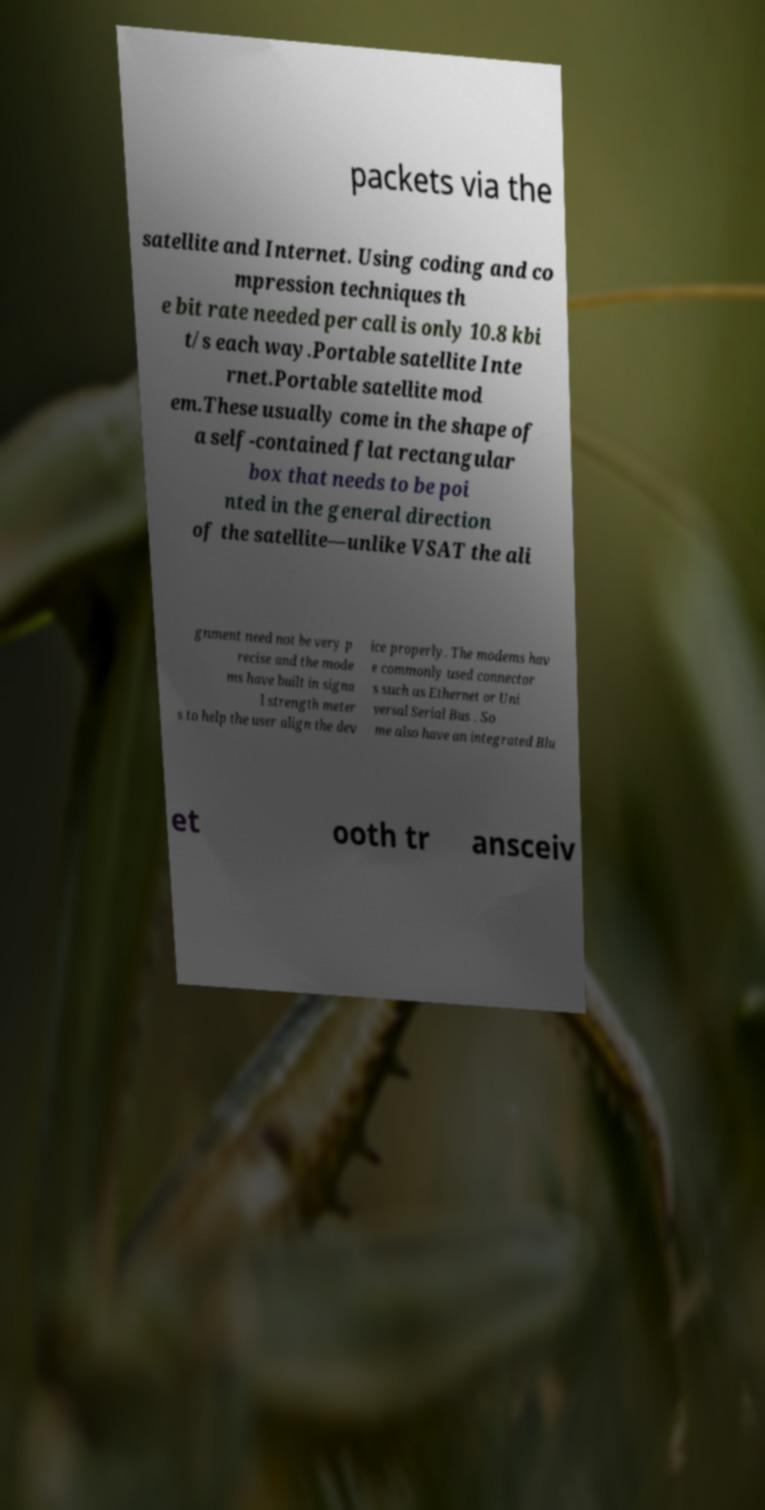Please identify and transcribe the text found in this image. packets via the satellite and Internet. Using coding and co mpression techniques th e bit rate needed per call is only 10.8 kbi t/s each way.Portable satellite Inte rnet.Portable satellite mod em.These usually come in the shape of a self-contained flat rectangular box that needs to be poi nted in the general direction of the satellite—unlike VSAT the ali gnment need not be very p recise and the mode ms have built in signa l strength meter s to help the user align the dev ice properly. The modems hav e commonly used connector s such as Ethernet or Uni versal Serial Bus . So me also have an integrated Blu et ooth tr ansceiv 